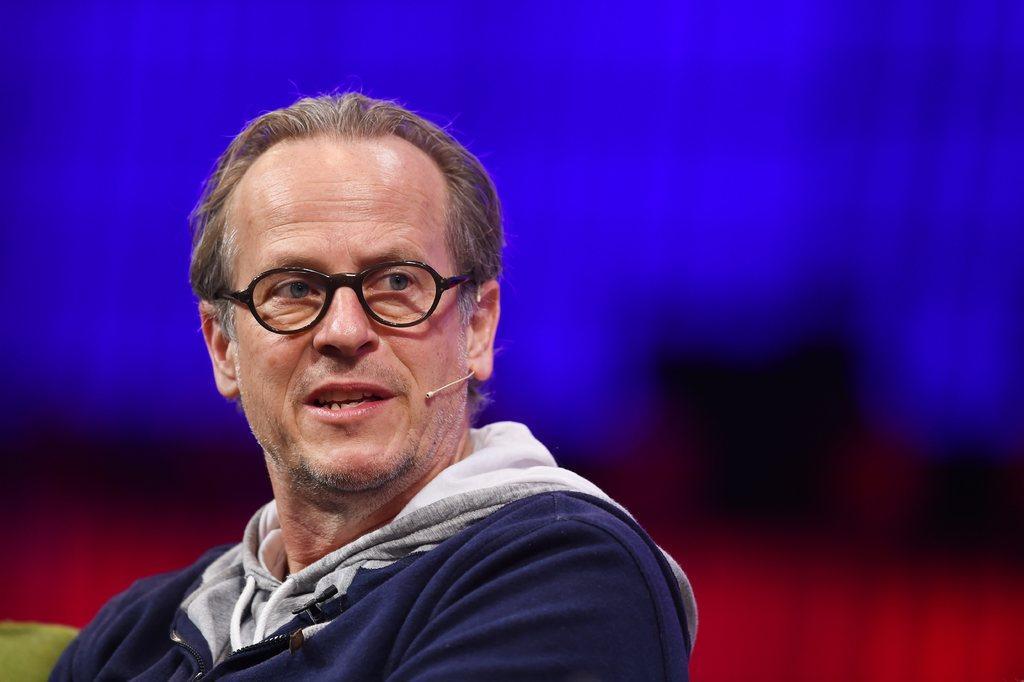Can you describe this image briefly? In this picture we can observe a person wearing blue color hoodie and spectacles. We can observe a mic near his ear. The background is in blue, black and red colors. 